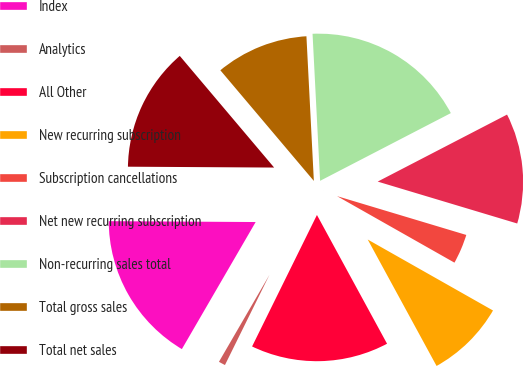Convert chart. <chart><loc_0><loc_0><loc_500><loc_500><pie_chart><fcel>Index<fcel>Analytics<fcel>All Other<fcel>New recurring subscription<fcel>Subscription cancellations<fcel>Net new recurring subscription<fcel>Non-recurring sales total<fcel>Total gross sales<fcel>Total net sales<nl><fcel>16.72%<fcel>1.08%<fcel>15.23%<fcel>8.86%<fcel>3.56%<fcel>12.25%<fcel>18.21%<fcel>10.35%<fcel>13.74%<nl></chart> 